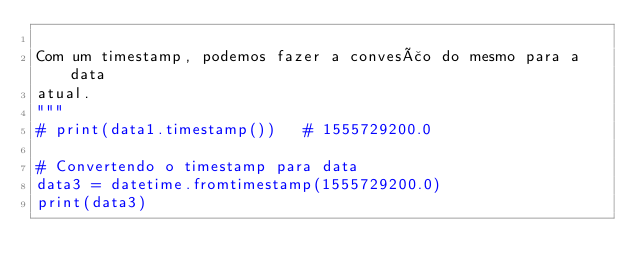Convert code to text. <code><loc_0><loc_0><loc_500><loc_500><_Python_>
Com um timestamp, podemos fazer a convesão do mesmo para a data
atual.
"""
# print(data1.timestamp())   # 1555729200.0

# Convertendo o timestamp para data
data3 = datetime.fromtimestamp(1555729200.0)
print(data3)
</code> 